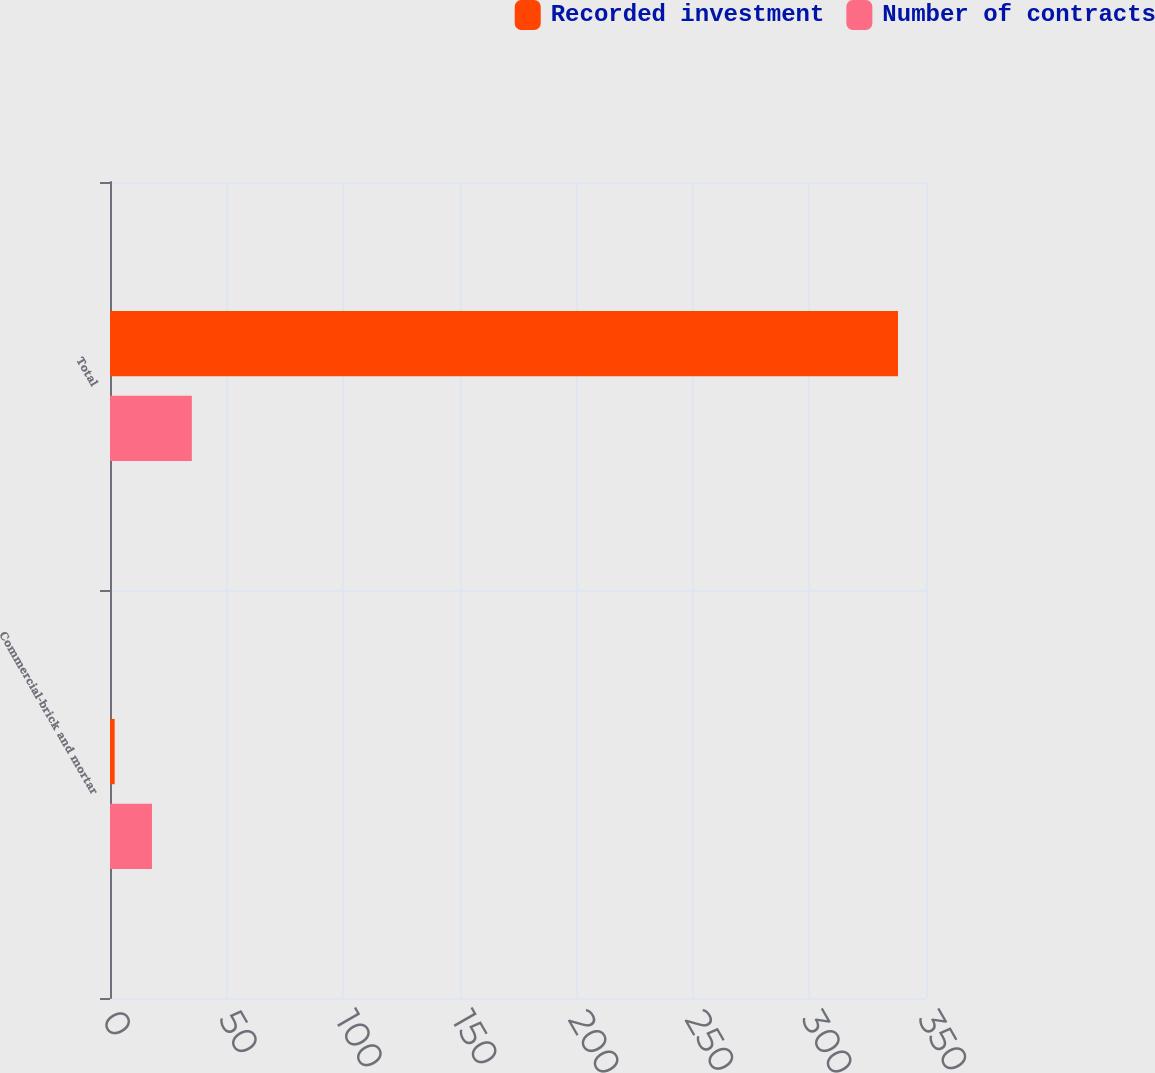Convert chart. <chart><loc_0><loc_0><loc_500><loc_500><stacked_bar_chart><ecel><fcel>Commercial-brick and mortar<fcel>Total<nl><fcel>Recorded investment<fcel>2<fcel>338<nl><fcel>Number of contracts<fcel>18<fcel>35.1<nl></chart> 